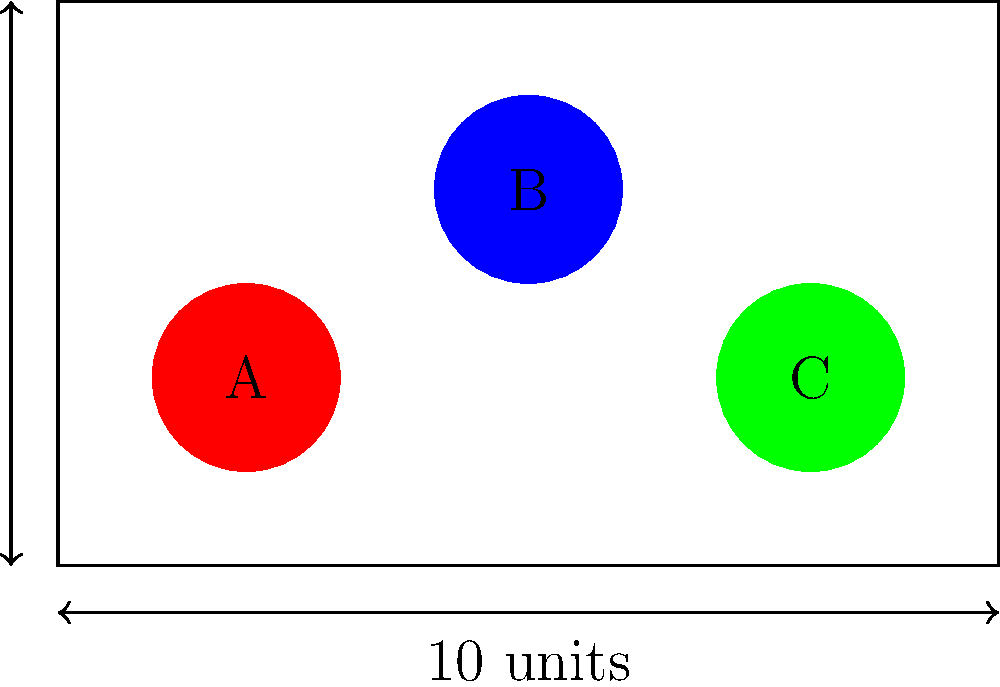You have a rectangular toy box with dimensions 10 units by 6 units. Three circular toys (A, B, and C) each have a diameter of 2 units. If you need to maximize the distance between the toys, what is the minimum distance between the centers of any two toys when optimally placed? To maximize the distance between the toys, we need to place them as far apart as possible within the given box. Here's how we can approach this:

1. The box dimensions are 10 units by 6 units.
2. Each toy has a diameter of 2 units, so its radius is 1 unit.
3. To maximize distance, we should place the toys in a triangular formation, with one toy in each corner of the box.
4. The centers of the toys should be 1 unit away from the edges of the box (due to their radius).

5. Let's calculate the distance between the centers:
   - Horizontal distance: 10 - 2 = 8 units (subtracting 2 units for the radii)
   - Vertical distance: 6 - 2 = 4 units (subtracting 2 units for the radii)

6. Now we can use the Pythagorean theorem to calculate the diagonal distance:
   $$d = \sqrt{8^2 + 4^2} = \sqrt{64 + 16} = \sqrt{80} = 4\sqrt{5} \approx 8.94$$

7. The minimum distance between any two toy centers will be the shorter of the horizontal (8 units) or diagonal distance (approximately 8.94 units).

Therefore, the minimum distance between the centers of any two toys when optimally placed is 8 units.
Answer: 8 units 